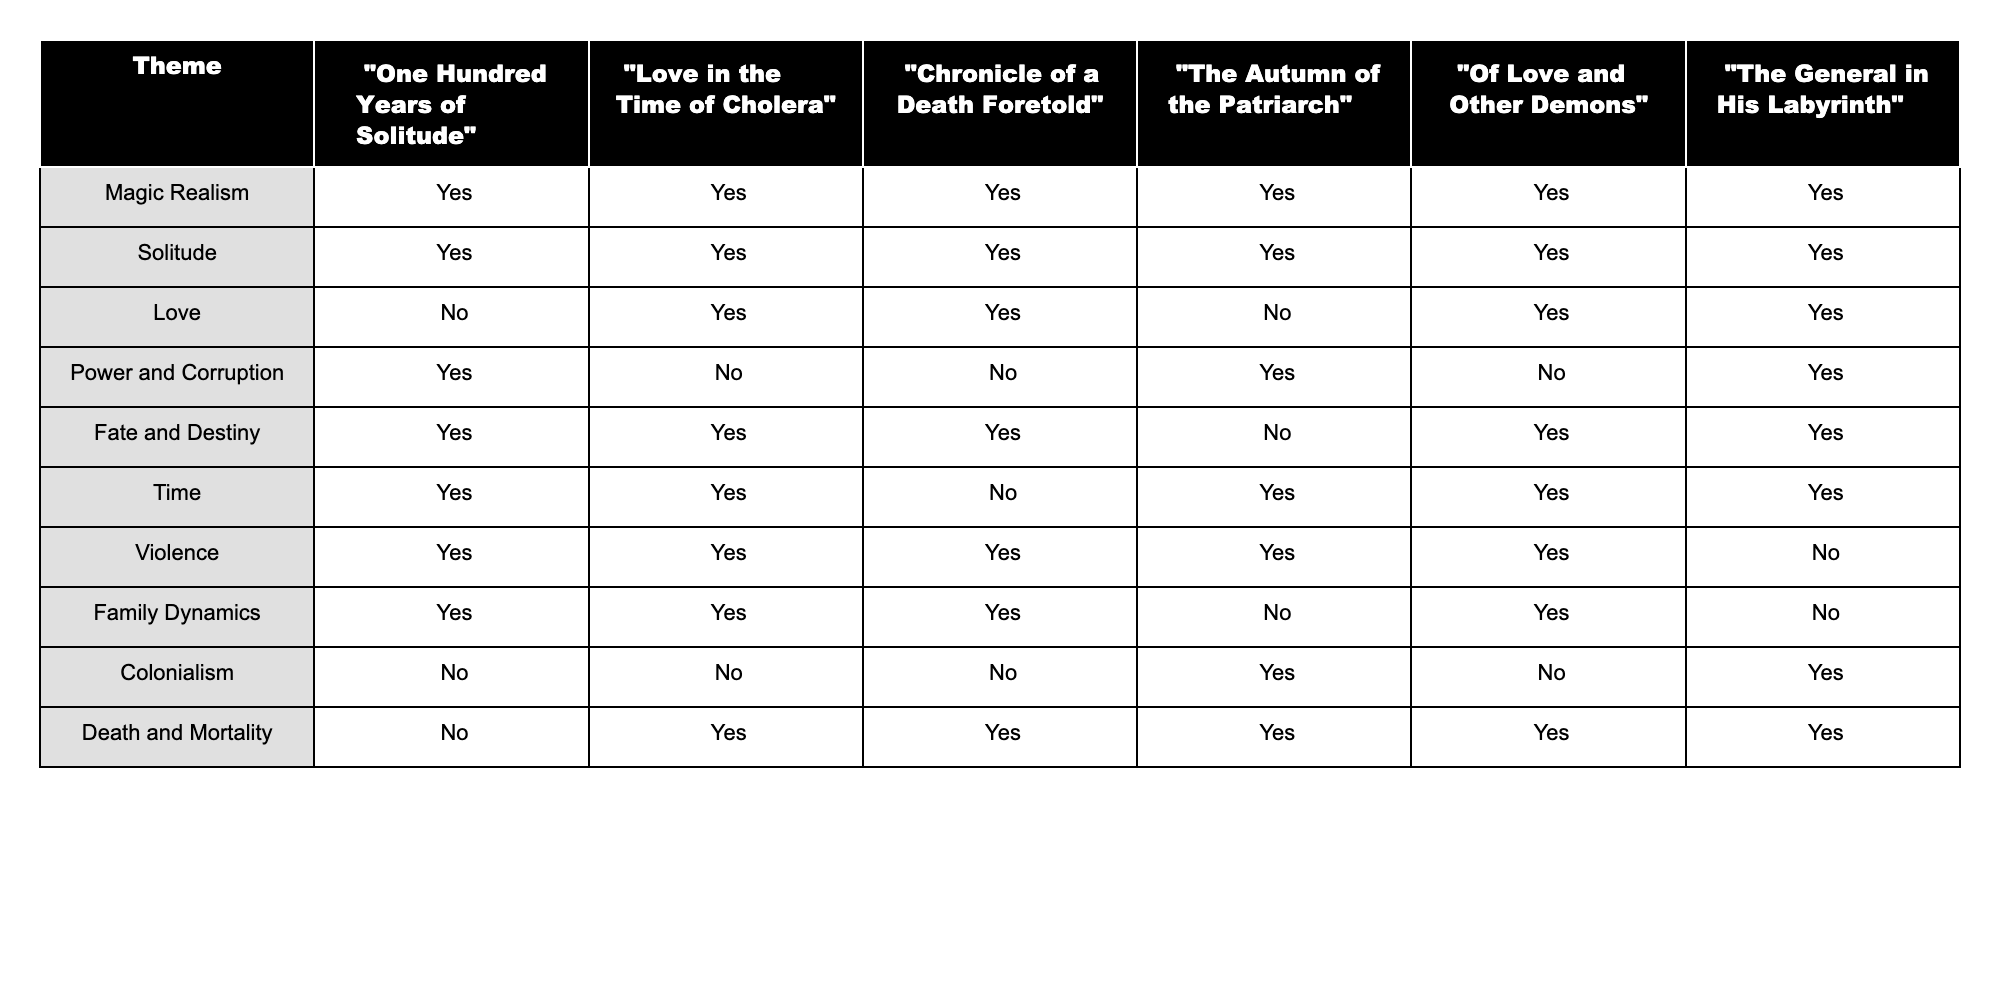What themes are explored in "One Hundred Years of Solitude"? The table indicates that "One Hundred Years of Solitude" explores the themes of Magic Realism, Solitude, Power and Corruption, Fate and Destiny, Time, Violence, Family Dynamics, and Death and Mortality, as all are marked with 'Yes'.
Answer: Magic Realism, Solitude, Power and Corruption, Fate and Destiny, Time, Violence, Family Dynamics, Death and Mortality Which novel does not explore the theme of Love at all? By examining the Love column, it shows that "One Hundred Years of Solitude" does not explore the theme of Love, as it is marked with 'No'.
Answer: "One Hundred Years of Solitude" How many novels explore the theme of Violence? The table shows that out of the six novels listed, all except "The General in His Labyrinth" explore the theme of Violence. This indicates that 5 novels incorporate this theme.
Answer: 5 Is the theme of Colonialism present in "Love in the Time of Cholera"? The table indicates the theme of Colonialism is marked with 'No' for "Love in the Time of Cholera," meaning it does not explore this theme.
Answer: No Which themes are common to both "Chronicle of a Death Foretold" and "Of Love and Other Demons"? By looking at the respective columns of both novels, we see that the common themes are Solitude, Love, Fate and Destiny, and Violence, as both novels have 'Yes' in these categories.
Answer: Solitude, Love, Fate and Destiny, Violence Which novel among those listed explores the theme of Power and Corruption but not the theme of Love? The table shows that "The Autumn of the Patriarch" explores Power and Corruption with 'Yes' and does not explore Love as it is marked with 'No'.
Answer: "The Autumn of the Patriarch" What is the total number of themes explored in "The General in His Labyrinth"? Looking at the table, "The General in His Labyrinth" explores the themes of Magic Realism, Solitude, Love, Fate and Destiny, Time, and Death and Mortality, totaling 6 themes explored.
Answer: 6 Does "Of Love and Other Demons" explore the theme of Solitude? The table shows that "Of Love and Other Demons" has 'Yes' marked for Solitude, indicating this theme is present in the novel.
Answer: Yes Which novel has the lowest number of themes explored, and what are they? By referring to the table, "The General in His Labyrinth" has the least unique themes as it covers all except for Colonialism and Violence, totaling to 4 themes, which implies it covers the themes of Magic Realism, Solitude, Love, and Fate and Destiny.
Answer: "The General in His Labyrinth"; Magic Realism, Solitude, Love, Fate and Destiny What unique themes are found in "The Autumn of the Patriarch"? The novel "The Autumn of the Patriarch" uniquely explores the themes of Power and Corruption, and Time, since these themes are not found in other novels mentioned.
Answer: Power and Corruption, Time How many themes are explored in total across all novels listed? By counting the total unique themes listed in the first column of the table, there are 10 unique themes explored across all the novels.
Answer: 10 